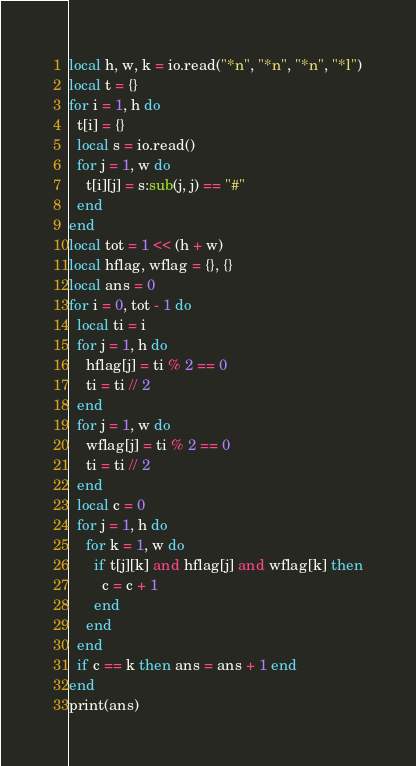<code> <loc_0><loc_0><loc_500><loc_500><_Lua_>local h, w, k = io.read("*n", "*n", "*n", "*l")
local t = {}
for i = 1, h do
  t[i] = {}
  local s = io.read()
  for j = 1, w do
    t[i][j] = s:sub(j, j) == "#"
  end
end
local tot = 1 << (h + w)
local hflag, wflag = {}, {}
local ans = 0
for i = 0, tot - 1 do
  local ti = i
  for j = 1, h do
    hflag[j] = ti % 2 == 0
    ti = ti // 2
  end
  for j = 1, w do
    wflag[j] = ti % 2 == 0
    ti = ti // 2
  end
  local c = 0
  for j = 1, h do
    for k = 1, w do
      if t[j][k] and hflag[j] and wflag[k] then
        c = c + 1
      end
    end
  end
  if c == k then ans = ans + 1 end
end
print(ans)
</code> 